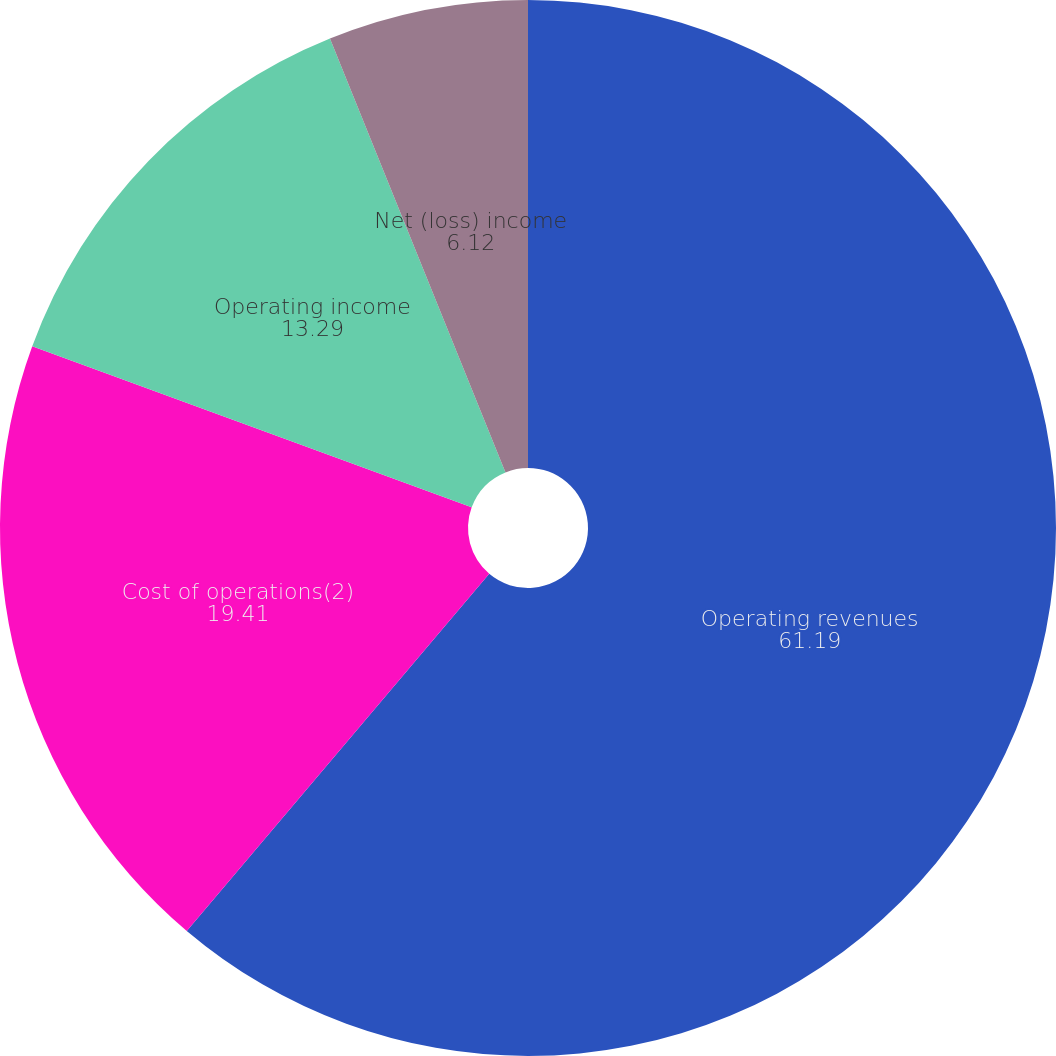Convert chart to OTSL. <chart><loc_0><loc_0><loc_500><loc_500><pie_chart><fcel>Operating revenues<fcel>Cost of operations(2)<fcel>Operating income<fcel>Net (loss) income<fcel>Basic and diluted net (loss)<nl><fcel>61.19%<fcel>19.41%<fcel>13.29%<fcel>6.12%<fcel>0.0%<nl></chart> 